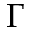Convert formula to latex. <formula><loc_0><loc_0><loc_500><loc_500>\Gamma</formula> 